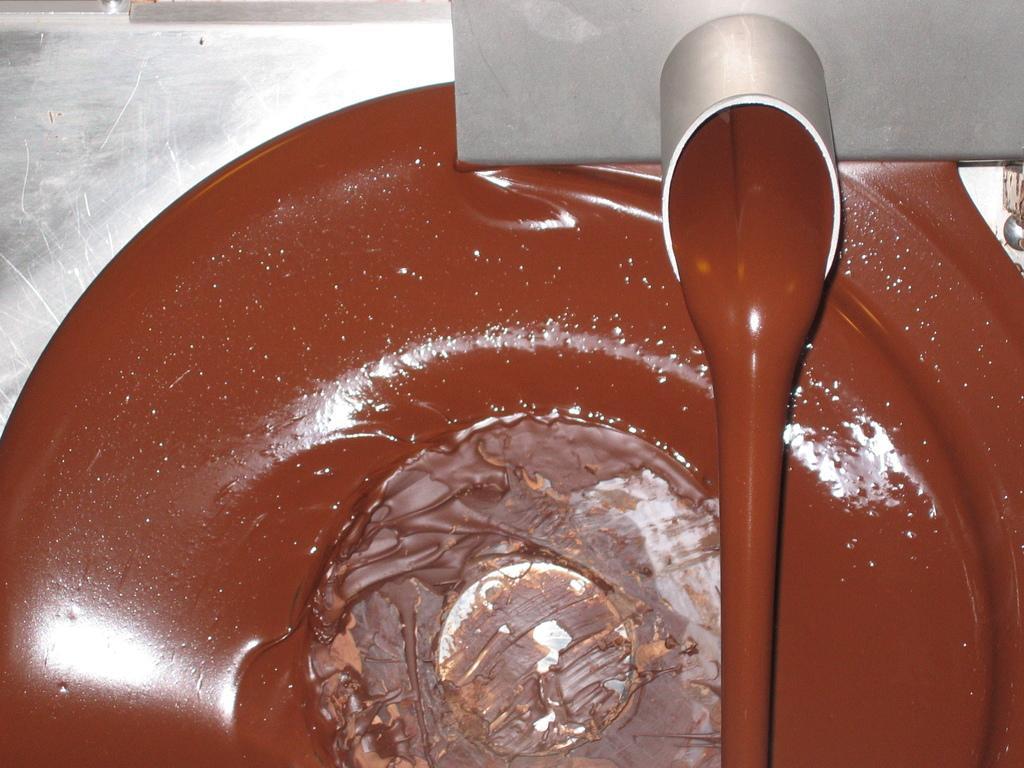How would you summarize this image in a sentence or two? In this picture we can see a chocolate machine. Here we can see melted chocolate. 